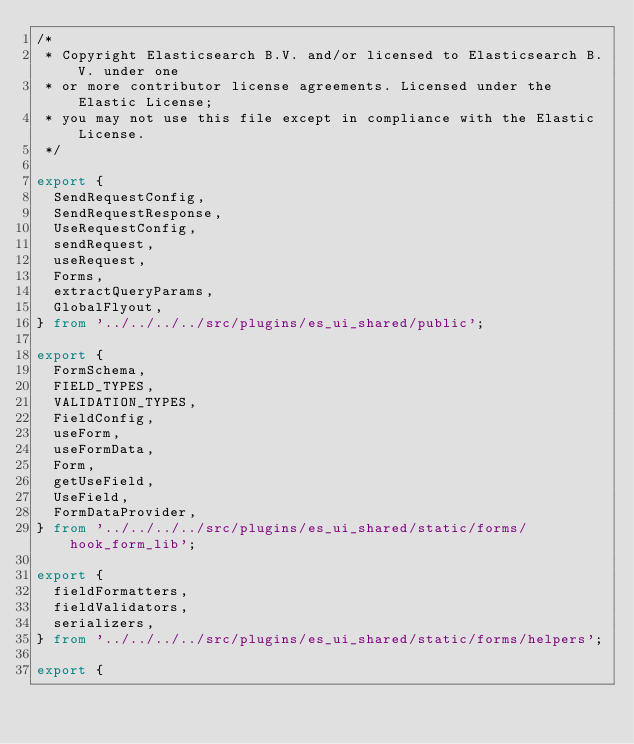Convert code to text. <code><loc_0><loc_0><loc_500><loc_500><_TypeScript_>/*
 * Copyright Elasticsearch B.V. and/or licensed to Elasticsearch B.V. under one
 * or more contributor license agreements. Licensed under the Elastic License;
 * you may not use this file except in compliance with the Elastic License.
 */

export {
  SendRequestConfig,
  SendRequestResponse,
  UseRequestConfig,
  sendRequest,
  useRequest,
  Forms,
  extractQueryParams,
  GlobalFlyout,
} from '../../../../src/plugins/es_ui_shared/public';

export {
  FormSchema,
  FIELD_TYPES,
  VALIDATION_TYPES,
  FieldConfig,
  useForm,
  useFormData,
  Form,
  getUseField,
  UseField,
  FormDataProvider,
} from '../../../../src/plugins/es_ui_shared/static/forms/hook_form_lib';

export {
  fieldFormatters,
  fieldValidators,
  serializers,
} from '../../../../src/plugins/es_ui_shared/static/forms/helpers';

export {</code> 